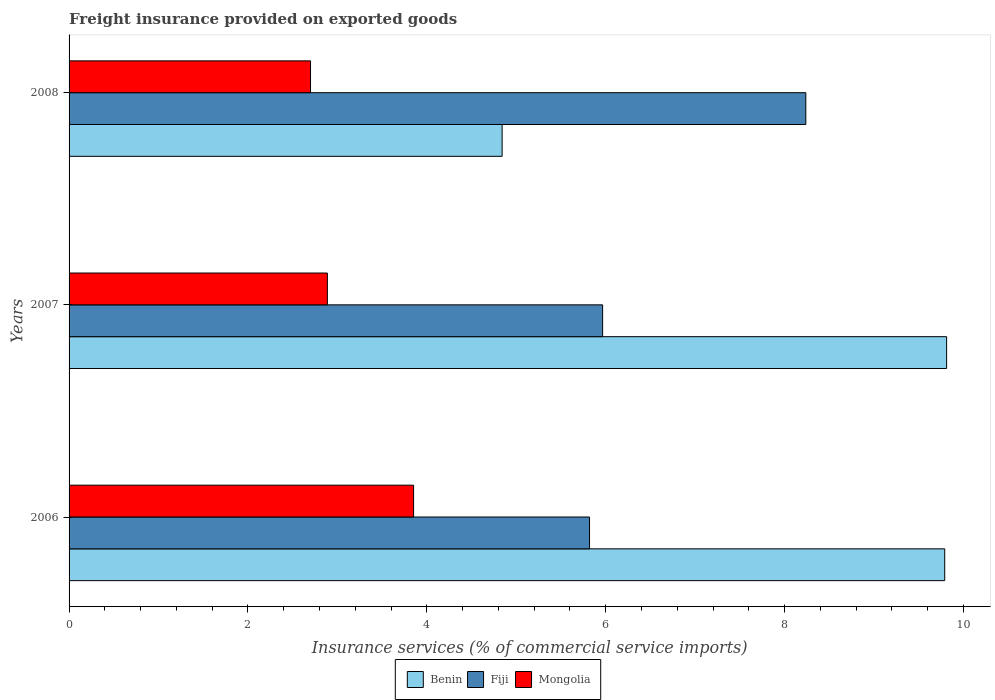How many different coloured bars are there?
Give a very brief answer. 3. How many groups of bars are there?
Make the answer very short. 3. Are the number of bars on each tick of the Y-axis equal?
Keep it short and to the point. Yes. What is the label of the 1st group of bars from the top?
Provide a succinct answer. 2008. In how many cases, is the number of bars for a given year not equal to the number of legend labels?
Ensure brevity in your answer.  0. What is the freight insurance provided on exported goods in Mongolia in 2008?
Provide a succinct answer. 2.7. Across all years, what is the maximum freight insurance provided on exported goods in Fiji?
Give a very brief answer. 8.24. Across all years, what is the minimum freight insurance provided on exported goods in Benin?
Give a very brief answer. 4.84. In which year was the freight insurance provided on exported goods in Fiji maximum?
Your answer should be very brief. 2008. What is the total freight insurance provided on exported goods in Mongolia in the graph?
Your answer should be very brief. 9.44. What is the difference between the freight insurance provided on exported goods in Benin in 2006 and that in 2008?
Give a very brief answer. 4.95. What is the difference between the freight insurance provided on exported goods in Benin in 2006 and the freight insurance provided on exported goods in Fiji in 2007?
Offer a very short reply. 3.82. What is the average freight insurance provided on exported goods in Benin per year?
Your response must be concise. 8.15. In the year 2006, what is the difference between the freight insurance provided on exported goods in Fiji and freight insurance provided on exported goods in Benin?
Provide a short and direct response. -3.97. What is the ratio of the freight insurance provided on exported goods in Mongolia in 2006 to that in 2007?
Offer a terse response. 1.33. Is the freight insurance provided on exported goods in Mongolia in 2007 less than that in 2008?
Provide a short and direct response. No. What is the difference between the highest and the second highest freight insurance provided on exported goods in Benin?
Offer a very short reply. 0.02. What is the difference between the highest and the lowest freight insurance provided on exported goods in Benin?
Your response must be concise. 4.97. What does the 1st bar from the top in 2008 represents?
Your answer should be compact. Mongolia. What does the 2nd bar from the bottom in 2007 represents?
Keep it short and to the point. Fiji. How many bars are there?
Ensure brevity in your answer.  9. Are all the bars in the graph horizontal?
Your response must be concise. Yes. Are the values on the major ticks of X-axis written in scientific E-notation?
Offer a very short reply. No. Where does the legend appear in the graph?
Your answer should be very brief. Bottom center. How are the legend labels stacked?
Your answer should be very brief. Horizontal. What is the title of the graph?
Provide a short and direct response. Freight insurance provided on exported goods. What is the label or title of the X-axis?
Offer a very short reply. Insurance services (% of commercial service imports). What is the label or title of the Y-axis?
Ensure brevity in your answer.  Years. What is the Insurance services (% of commercial service imports) in Benin in 2006?
Keep it short and to the point. 9.79. What is the Insurance services (% of commercial service imports) in Fiji in 2006?
Ensure brevity in your answer.  5.82. What is the Insurance services (% of commercial service imports) in Mongolia in 2006?
Your answer should be compact. 3.85. What is the Insurance services (% of commercial service imports) of Benin in 2007?
Your answer should be compact. 9.81. What is the Insurance services (% of commercial service imports) in Fiji in 2007?
Make the answer very short. 5.97. What is the Insurance services (% of commercial service imports) of Mongolia in 2007?
Give a very brief answer. 2.89. What is the Insurance services (% of commercial service imports) of Benin in 2008?
Give a very brief answer. 4.84. What is the Insurance services (% of commercial service imports) of Fiji in 2008?
Keep it short and to the point. 8.24. What is the Insurance services (% of commercial service imports) of Mongolia in 2008?
Provide a succinct answer. 2.7. Across all years, what is the maximum Insurance services (% of commercial service imports) of Benin?
Your answer should be compact. 9.81. Across all years, what is the maximum Insurance services (% of commercial service imports) of Fiji?
Your answer should be very brief. 8.24. Across all years, what is the maximum Insurance services (% of commercial service imports) of Mongolia?
Offer a terse response. 3.85. Across all years, what is the minimum Insurance services (% of commercial service imports) of Benin?
Ensure brevity in your answer.  4.84. Across all years, what is the minimum Insurance services (% of commercial service imports) of Fiji?
Give a very brief answer. 5.82. Across all years, what is the minimum Insurance services (% of commercial service imports) of Mongolia?
Your response must be concise. 2.7. What is the total Insurance services (% of commercial service imports) in Benin in the graph?
Your answer should be very brief. 24.44. What is the total Insurance services (% of commercial service imports) of Fiji in the graph?
Keep it short and to the point. 20.02. What is the total Insurance services (% of commercial service imports) of Mongolia in the graph?
Give a very brief answer. 9.44. What is the difference between the Insurance services (% of commercial service imports) of Benin in 2006 and that in 2007?
Give a very brief answer. -0.02. What is the difference between the Insurance services (% of commercial service imports) of Fiji in 2006 and that in 2007?
Your answer should be compact. -0.15. What is the difference between the Insurance services (% of commercial service imports) of Benin in 2006 and that in 2008?
Make the answer very short. 4.95. What is the difference between the Insurance services (% of commercial service imports) of Fiji in 2006 and that in 2008?
Give a very brief answer. -2.42. What is the difference between the Insurance services (% of commercial service imports) in Mongolia in 2006 and that in 2008?
Ensure brevity in your answer.  1.15. What is the difference between the Insurance services (% of commercial service imports) of Benin in 2007 and that in 2008?
Provide a succinct answer. 4.97. What is the difference between the Insurance services (% of commercial service imports) of Fiji in 2007 and that in 2008?
Provide a succinct answer. -2.27. What is the difference between the Insurance services (% of commercial service imports) in Mongolia in 2007 and that in 2008?
Provide a succinct answer. 0.19. What is the difference between the Insurance services (% of commercial service imports) in Benin in 2006 and the Insurance services (% of commercial service imports) in Fiji in 2007?
Provide a succinct answer. 3.82. What is the difference between the Insurance services (% of commercial service imports) of Benin in 2006 and the Insurance services (% of commercial service imports) of Mongolia in 2007?
Your answer should be very brief. 6.9. What is the difference between the Insurance services (% of commercial service imports) of Fiji in 2006 and the Insurance services (% of commercial service imports) of Mongolia in 2007?
Provide a short and direct response. 2.93. What is the difference between the Insurance services (% of commercial service imports) of Benin in 2006 and the Insurance services (% of commercial service imports) of Fiji in 2008?
Provide a succinct answer. 1.55. What is the difference between the Insurance services (% of commercial service imports) of Benin in 2006 and the Insurance services (% of commercial service imports) of Mongolia in 2008?
Ensure brevity in your answer.  7.09. What is the difference between the Insurance services (% of commercial service imports) in Fiji in 2006 and the Insurance services (% of commercial service imports) in Mongolia in 2008?
Your answer should be compact. 3.12. What is the difference between the Insurance services (% of commercial service imports) in Benin in 2007 and the Insurance services (% of commercial service imports) in Fiji in 2008?
Provide a succinct answer. 1.57. What is the difference between the Insurance services (% of commercial service imports) in Benin in 2007 and the Insurance services (% of commercial service imports) in Mongolia in 2008?
Ensure brevity in your answer.  7.11. What is the difference between the Insurance services (% of commercial service imports) of Fiji in 2007 and the Insurance services (% of commercial service imports) of Mongolia in 2008?
Offer a very short reply. 3.27. What is the average Insurance services (% of commercial service imports) in Benin per year?
Make the answer very short. 8.15. What is the average Insurance services (% of commercial service imports) in Fiji per year?
Provide a short and direct response. 6.67. What is the average Insurance services (% of commercial service imports) of Mongolia per year?
Make the answer very short. 3.15. In the year 2006, what is the difference between the Insurance services (% of commercial service imports) of Benin and Insurance services (% of commercial service imports) of Fiji?
Keep it short and to the point. 3.97. In the year 2006, what is the difference between the Insurance services (% of commercial service imports) of Benin and Insurance services (% of commercial service imports) of Mongolia?
Offer a very short reply. 5.94. In the year 2006, what is the difference between the Insurance services (% of commercial service imports) in Fiji and Insurance services (% of commercial service imports) in Mongolia?
Ensure brevity in your answer.  1.97. In the year 2007, what is the difference between the Insurance services (% of commercial service imports) of Benin and Insurance services (% of commercial service imports) of Fiji?
Make the answer very short. 3.85. In the year 2007, what is the difference between the Insurance services (% of commercial service imports) in Benin and Insurance services (% of commercial service imports) in Mongolia?
Offer a terse response. 6.92. In the year 2007, what is the difference between the Insurance services (% of commercial service imports) in Fiji and Insurance services (% of commercial service imports) in Mongolia?
Make the answer very short. 3.08. In the year 2008, what is the difference between the Insurance services (% of commercial service imports) of Benin and Insurance services (% of commercial service imports) of Fiji?
Provide a succinct answer. -3.4. In the year 2008, what is the difference between the Insurance services (% of commercial service imports) in Benin and Insurance services (% of commercial service imports) in Mongolia?
Provide a short and direct response. 2.14. In the year 2008, what is the difference between the Insurance services (% of commercial service imports) in Fiji and Insurance services (% of commercial service imports) in Mongolia?
Provide a short and direct response. 5.54. What is the ratio of the Insurance services (% of commercial service imports) of Benin in 2006 to that in 2007?
Offer a very short reply. 1. What is the ratio of the Insurance services (% of commercial service imports) in Fiji in 2006 to that in 2007?
Your answer should be very brief. 0.98. What is the ratio of the Insurance services (% of commercial service imports) of Mongolia in 2006 to that in 2007?
Your answer should be compact. 1.33. What is the ratio of the Insurance services (% of commercial service imports) in Benin in 2006 to that in 2008?
Provide a succinct answer. 2.02. What is the ratio of the Insurance services (% of commercial service imports) in Fiji in 2006 to that in 2008?
Provide a short and direct response. 0.71. What is the ratio of the Insurance services (% of commercial service imports) in Mongolia in 2006 to that in 2008?
Provide a succinct answer. 1.43. What is the ratio of the Insurance services (% of commercial service imports) in Benin in 2007 to that in 2008?
Your answer should be very brief. 2.03. What is the ratio of the Insurance services (% of commercial service imports) in Fiji in 2007 to that in 2008?
Give a very brief answer. 0.72. What is the ratio of the Insurance services (% of commercial service imports) in Mongolia in 2007 to that in 2008?
Make the answer very short. 1.07. What is the difference between the highest and the second highest Insurance services (% of commercial service imports) in Benin?
Provide a succinct answer. 0.02. What is the difference between the highest and the second highest Insurance services (% of commercial service imports) of Fiji?
Provide a succinct answer. 2.27. What is the difference between the highest and the lowest Insurance services (% of commercial service imports) of Benin?
Your response must be concise. 4.97. What is the difference between the highest and the lowest Insurance services (% of commercial service imports) of Fiji?
Provide a short and direct response. 2.42. What is the difference between the highest and the lowest Insurance services (% of commercial service imports) in Mongolia?
Give a very brief answer. 1.15. 